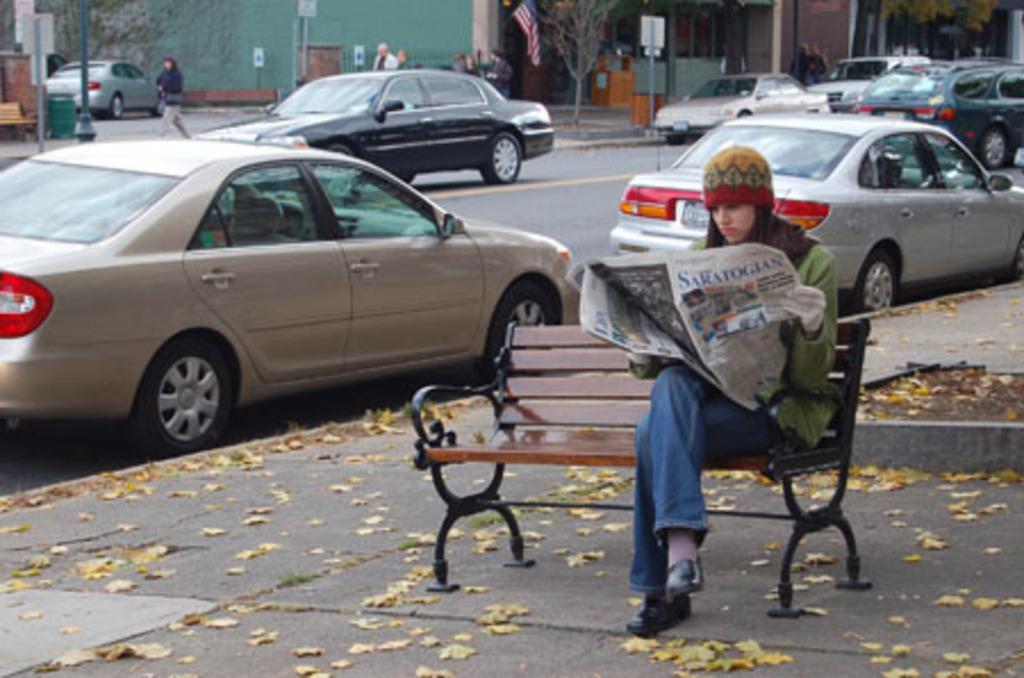Describe this image in one or two sentences. On the right side of this image I can see a woman reading the newspaper by sitting on a bench which is placed on the footpath. On the left side, I can see few cars on the road. In the background there are some buildings and few people are walking on the road. Beside the road, I can see few poles. 